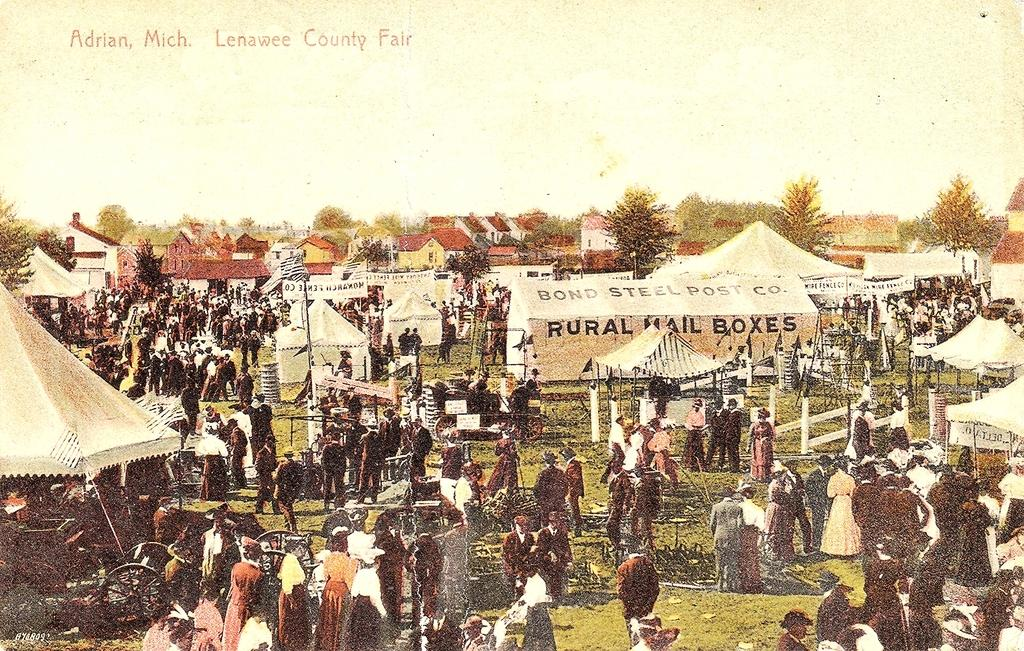<image>
Summarize the visual content of the image. an old fair ground picture from Adrian, Mich 